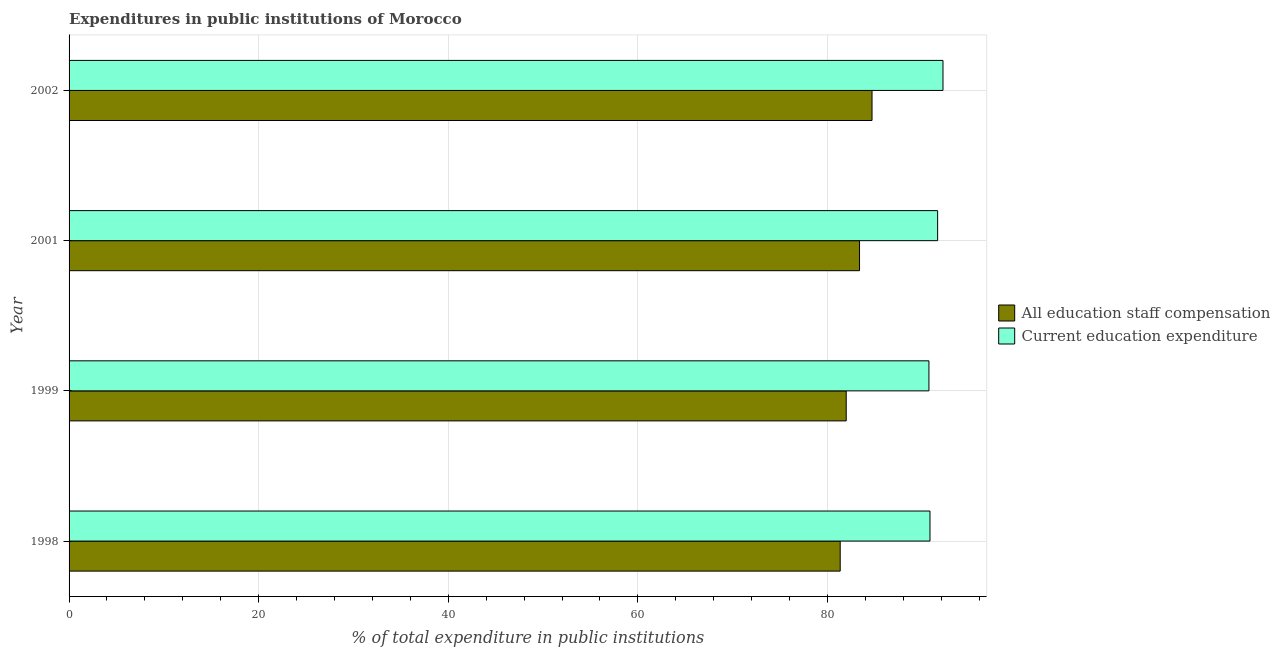How many different coloured bars are there?
Give a very brief answer. 2. How many groups of bars are there?
Your response must be concise. 4. Are the number of bars per tick equal to the number of legend labels?
Give a very brief answer. Yes. How many bars are there on the 3rd tick from the top?
Make the answer very short. 2. In how many cases, is the number of bars for a given year not equal to the number of legend labels?
Offer a very short reply. 0. What is the expenditure in staff compensation in 1998?
Your response must be concise. 81.35. Across all years, what is the maximum expenditure in education?
Provide a succinct answer. 92.19. Across all years, what is the minimum expenditure in staff compensation?
Provide a succinct answer. 81.35. In which year was the expenditure in education minimum?
Make the answer very short. 1999. What is the total expenditure in education in the graph?
Offer a terse response. 365.35. What is the difference between the expenditure in staff compensation in 2001 and that in 2002?
Your answer should be very brief. -1.32. What is the difference between the expenditure in staff compensation in 1999 and the expenditure in education in 2001?
Your answer should be compact. -9.64. What is the average expenditure in education per year?
Offer a terse response. 91.34. In the year 1999, what is the difference between the expenditure in education and expenditure in staff compensation?
Give a very brief answer. 8.73. Is the difference between the expenditure in staff compensation in 1999 and 2002 greater than the difference between the expenditure in education in 1999 and 2002?
Your response must be concise. No. What is the difference between the highest and the second highest expenditure in education?
Your answer should be compact. 0.56. What is the difference between the highest and the lowest expenditure in education?
Provide a succinct answer. 1.48. Is the sum of the expenditure in education in 1999 and 2001 greater than the maximum expenditure in staff compensation across all years?
Offer a terse response. Yes. What does the 2nd bar from the top in 2001 represents?
Provide a succinct answer. All education staff compensation. What does the 2nd bar from the bottom in 2001 represents?
Give a very brief answer. Current education expenditure. How many bars are there?
Offer a very short reply. 8. Are all the bars in the graph horizontal?
Offer a terse response. Yes. How many years are there in the graph?
Keep it short and to the point. 4. What is the difference between two consecutive major ticks on the X-axis?
Provide a short and direct response. 20. Does the graph contain any zero values?
Provide a succinct answer. No. How many legend labels are there?
Offer a very short reply. 2. How are the legend labels stacked?
Give a very brief answer. Vertical. What is the title of the graph?
Your answer should be compact. Expenditures in public institutions of Morocco. Does "Infant" appear as one of the legend labels in the graph?
Your answer should be very brief. No. What is the label or title of the X-axis?
Your response must be concise. % of total expenditure in public institutions. What is the % of total expenditure in public institutions in All education staff compensation in 1998?
Make the answer very short. 81.35. What is the % of total expenditure in public institutions in Current education expenditure in 1998?
Keep it short and to the point. 90.82. What is the % of total expenditure in public institutions of All education staff compensation in 1999?
Give a very brief answer. 81.98. What is the % of total expenditure in public institutions in Current education expenditure in 1999?
Keep it short and to the point. 90.71. What is the % of total expenditure in public institutions of All education staff compensation in 2001?
Provide a short and direct response. 83.39. What is the % of total expenditure in public institutions in Current education expenditure in 2001?
Make the answer very short. 91.63. What is the % of total expenditure in public institutions of All education staff compensation in 2002?
Ensure brevity in your answer.  84.71. What is the % of total expenditure in public institutions of Current education expenditure in 2002?
Provide a succinct answer. 92.19. Across all years, what is the maximum % of total expenditure in public institutions in All education staff compensation?
Offer a terse response. 84.71. Across all years, what is the maximum % of total expenditure in public institutions of Current education expenditure?
Provide a succinct answer. 92.19. Across all years, what is the minimum % of total expenditure in public institutions in All education staff compensation?
Your answer should be very brief. 81.35. Across all years, what is the minimum % of total expenditure in public institutions in Current education expenditure?
Keep it short and to the point. 90.71. What is the total % of total expenditure in public institutions in All education staff compensation in the graph?
Provide a short and direct response. 331.43. What is the total % of total expenditure in public institutions of Current education expenditure in the graph?
Ensure brevity in your answer.  365.35. What is the difference between the % of total expenditure in public institutions of All education staff compensation in 1998 and that in 1999?
Give a very brief answer. -0.63. What is the difference between the % of total expenditure in public institutions in Current education expenditure in 1998 and that in 1999?
Offer a very short reply. 0.11. What is the difference between the % of total expenditure in public institutions in All education staff compensation in 1998 and that in 2001?
Offer a terse response. -2.04. What is the difference between the % of total expenditure in public institutions in Current education expenditure in 1998 and that in 2001?
Your answer should be very brief. -0.81. What is the difference between the % of total expenditure in public institutions in All education staff compensation in 1998 and that in 2002?
Give a very brief answer. -3.36. What is the difference between the % of total expenditure in public institutions in Current education expenditure in 1998 and that in 2002?
Offer a terse response. -1.37. What is the difference between the % of total expenditure in public institutions in All education staff compensation in 1999 and that in 2001?
Give a very brief answer. -1.4. What is the difference between the % of total expenditure in public institutions of Current education expenditure in 1999 and that in 2001?
Offer a terse response. -0.92. What is the difference between the % of total expenditure in public institutions of All education staff compensation in 1999 and that in 2002?
Your response must be concise. -2.72. What is the difference between the % of total expenditure in public institutions in Current education expenditure in 1999 and that in 2002?
Your answer should be compact. -1.48. What is the difference between the % of total expenditure in public institutions of All education staff compensation in 2001 and that in 2002?
Offer a very short reply. -1.32. What is the difference between the % of total expenditure in public institutions in Current education expenditure in 2001 and that in 2002?
Your answer should be very brief. -0.57. What is the difference between the % of total expenditure in public institutions in All education staff compensation in 1998 and the % of total expenditure in public institutions in Current education expenditure in 1999?
Offer a terse response. -9.36. What is the difference between the % of total expenditure in public institutions in All education staff compensation in 1998 and the % of total expenditure in public institutions in Current education expenditure in 2001?
Make the answer very short. -10.28. What is the difference between the % of total expenditure in public institutions of All education staff compensation in 1998 and the % of total expenditure in public institutions of Current education expenditure in 2002?
Offer a very short reply. -10.84. What is the difference between the % of total expenditure in public institutions of All education staff compensation in 1999 and the % of total expenditure in public institutions of Current education expenditure in 2001?
Your response must be concise. -9.64. What is the difference between the % of total expenditure in public institutions in All education staff compensation in 1999 and the % of total expenditure in public institutions in Current education expenditure in 2002?
Give a very brief answer. -10.21. What is the difference between the % of total expenditure in public institutions of All education staff compensation in 2001 and the % of total expenditure in public institutions of Current education expenditure in 2002?
Offer a very short reply. -8.8. What is the average % of total expenditure in public institutions in All education staff compensation per year?
Give a very brief answer. 82.86. What is the average % of total expenditure in public institutions of Current education expenditure per year?
Give a very brief answer. 91.34. In the year 1998, what is the difference between the % of total expenditure in public institutions of All education staff compensation and % of total expenditure in public institutions of Current education expenditure?
Offer a very short reply. -9.47. In the year 1999, what is the difference between the % of total expenditure in public institutions of All education staff compensation and % of total expenditure in public institutions of Current education expenditure?
Provide a short and direct response. -8.73. In the year 2001, what is the difference between the % of total expenditure in public institutions in All education staff compensation and % of total expenditure in public institutions in Current education expenditure?
Keep it short and to the point. -8.24. In the year 2002, what is the difference between the % of total expenditure in public institutions of All education staff compensation and % of total expenditure in public institutions of Current education expenditure?
Your response must be concise. -7.49. What is the ratio of the % of total expenditure in public institutions in All education staff compensation in 1998 to that in 1999?
Make the answer very short. 0.99. What is the ratio of the % of total expenditure in public institutions in All education staff compensation in 1998 to that in 2001?
Provide a short and direct response. 0.98. What is the ratio of the % of total expenditure in public institutions of Current education expenditure in 1998 to that in 2001?
Keep it short and to the point. 0.99. What is the ratio of the % of total expenditure in public institutions in All education staff compensation in 1998 to that in 2002?
Make the answer very short. 0.96. What is the ratio of the % of total expenditure in public institutions of Current education expenditure in 1998 to that in 2002?
Your answer should be compact. 0.99. What is the ratio of the % of total expenditure in public institutions of All education staff compensation in 1999 to that in 2001?
Offer a terse response. 0.98. What is the ratio of the % of total expenditure in public institutions in All education staff compensation in 1999 to that in 2002?
Your answer should be very brief. 0.97. What is the ratio of the % of total expenditure in public institutions of Current education expenditure in 1999 to that in 2002?
Your response must be concise. 0.98. What is the ratio of the % of total expenditure in public institutions in All education staff compensation in 2001 to that in 2002?
Ensure brevity in your answer.  0.98. What is the ratio of the % of total expenditure in public institutions of Current education expenditure in 2001 to that in 2002?
Offer a terse response. 0.99. What is the difference between the highest and the second highest % of total expenditure in public institutions in All education staff compensation?
Your answer should be very brief. 1.32. What is the difference between the highest and the second highest % of total expenditure in public institutions of Current education expenditure?
Provide a short and direct response. 0.57. What is the difference between the highest and the lowest % of total expenditure in public institutions in All education staff compensation?
Ensure brevity in your answer.  3.36. What is the difference between the highest and the lowest % of total expenditure in public institutions of Current education expenditure?
Give a very brief answer. 1.48. 